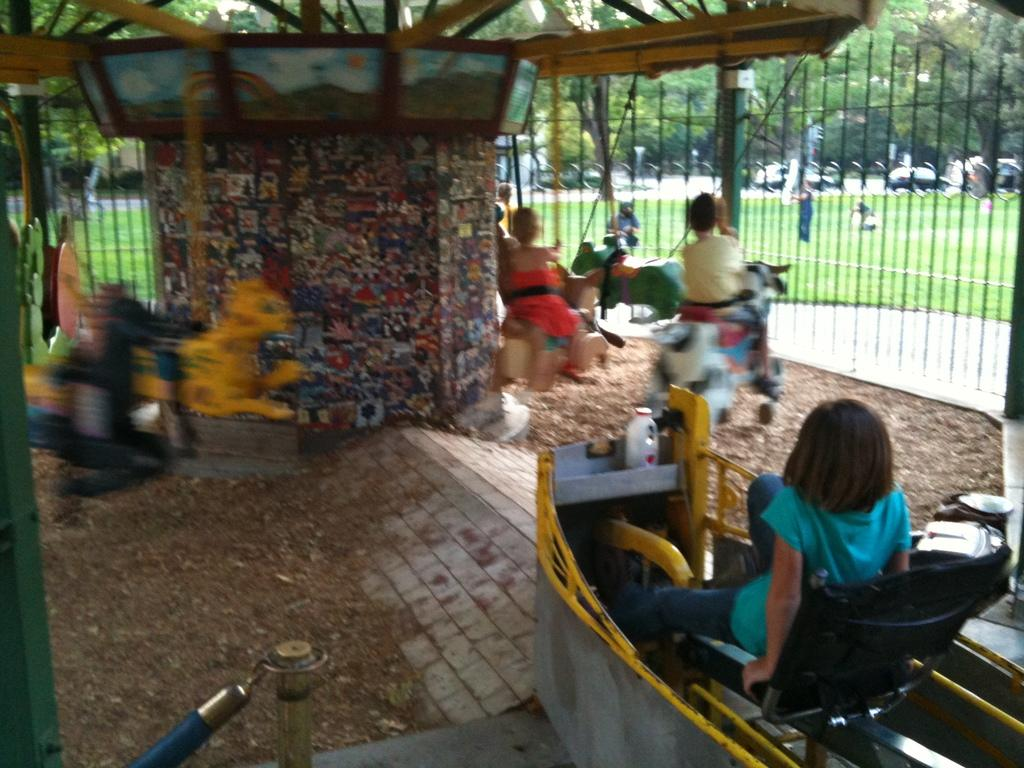Who or what can be seen in the image? There are people in the image. What type of activity is taking place in the image? There is a ride in the image, which suggests a recreational or amusement park setting. What is the purpose of the fence in the image? The fence in the image may serve as a boundary or safety measure. Can you describe the objects in the image? The objects in the image could include various items related to the ride or the surrounding area. What can be seen in the background of the image? In the background of the image, there is grass, trees, and additional persons. What type of fact can be seen in the image? There is no fact present in the image; it is a visual representation of a scene with people, a ride, a fence, objects, and a background. How many beads are visible on the ride in the image? There are no beads present in the image; the ride is not described as having beads as part of its design or decoration. 